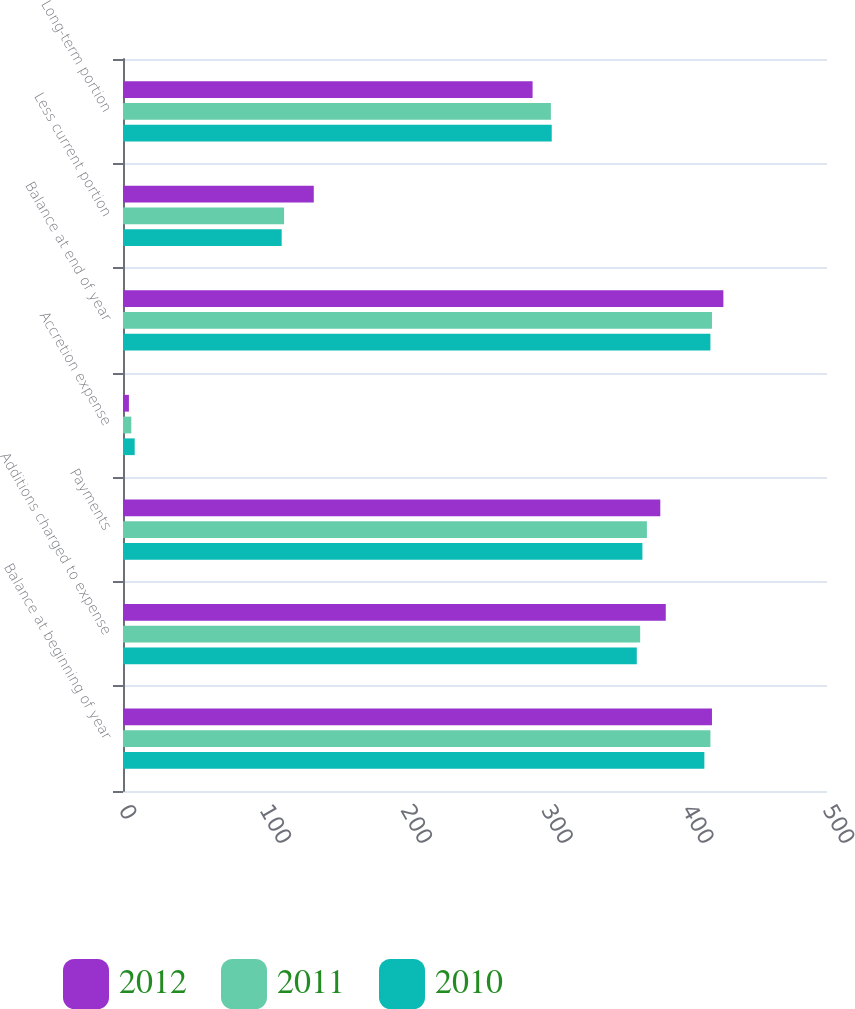<chart> <loc_0><loc_0><loc_500><loc_500><stacked_bar_chart><ecel><fcel>Balance at beginning of year<fcel>Additions charged to expense<fcel>Payments<fcel>Accretion expense<fcel>Balance at end of year<fcel>Less current portion<fcel>Long-term portion<nl><fcel>2012<fcel>418.3<fcel>385.5<fcel>381.6<fcel>4.2<fcel>426.4<fcel>135.5<fcel>290.9<nl><fcel>2011<fcel>417.2<fcel>367.3<fcel>372.1<fcel>5.9<fcel>418.3<fcel>114.4<fcel>303.9<nl><fcel>2010<fcel>412.9<fcel>364.9<fcel>368.9<fcel>8.3<fcel>417.2<fcel>112.7<fcel>304.5<nl></chart> 